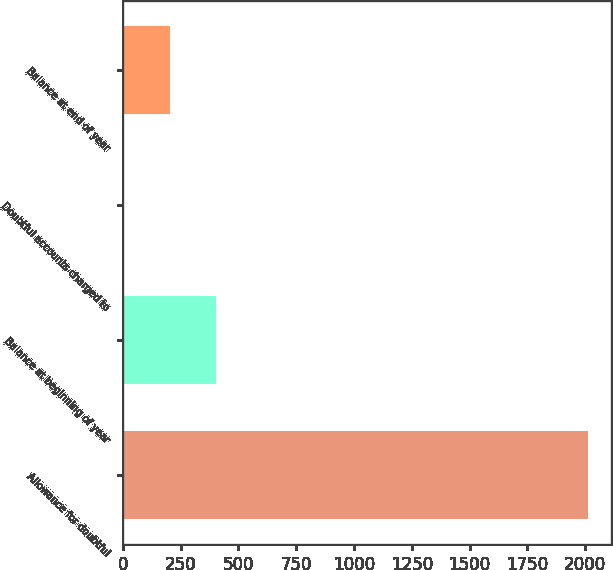<chart> <loc_0><loc_0><loc_500><loc_500><bar_chart><fcel>Allowance for doubtful<fcel>Balance at beginning of year<fcel>Doubtful accounts charged to<fcel>Balance at end of year<nl><fcel>2012<fcel>404.8<fcel>3<fcel>203.9<nl></chart> 